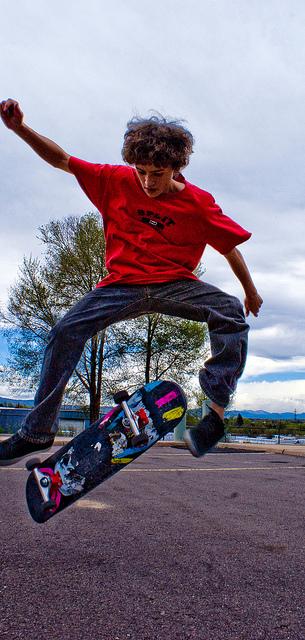What color is the skateboard?
Write a very short answer. Multi. What is he doing?
Be succinct. Skateboarding. Did a car leak some kind of fluid in the parking space?
Be succinct. No. Is this his first day doing this sport?
Concise answer only. No. 